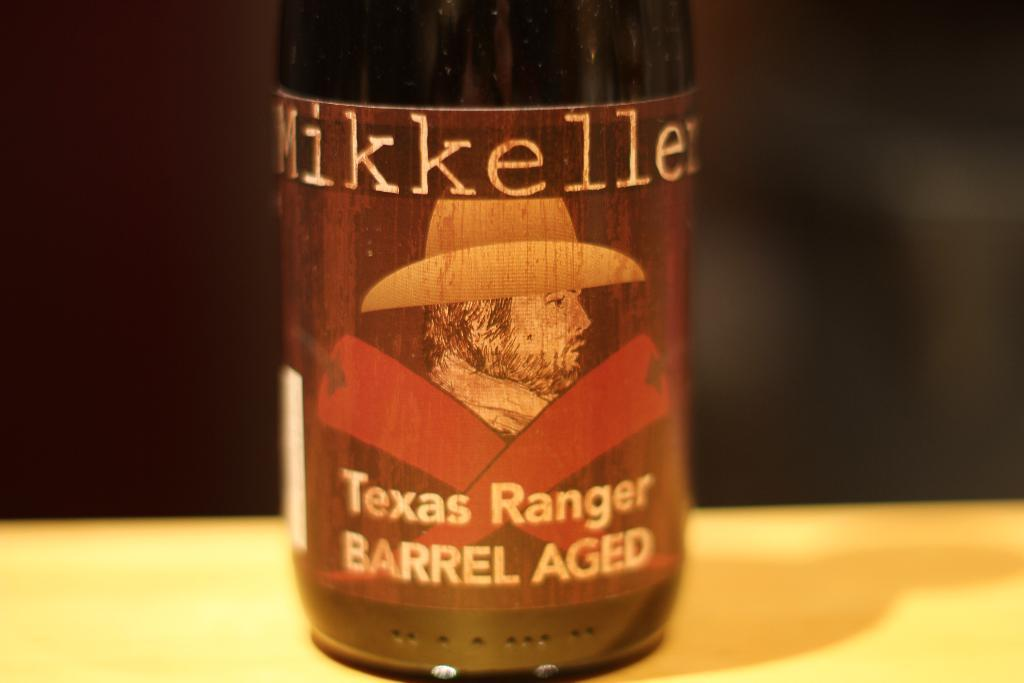<image>
Relay a brief, clear account of the picture shown. A beer bottle on a wooden table is labeled Texas Ranger Barrel Aged. 